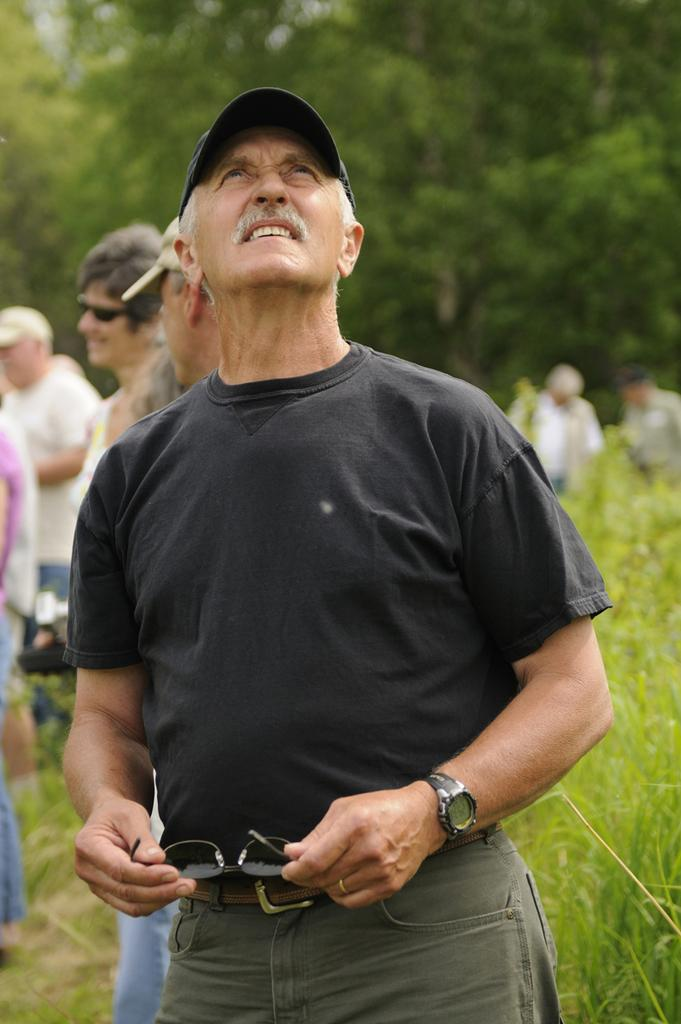What is the person in the foreground of the image holding? The person is holding spectacles in the image. Can you describe the setting in the background of the image? There is grass and a tree visible in the background of the image. Are there any other people present in the image? Yes, there are other persons visible in the background of the image. What type of frame is the person in the image using to express disgust? There is no frame present in the image, and the person is not expressing disgust. 